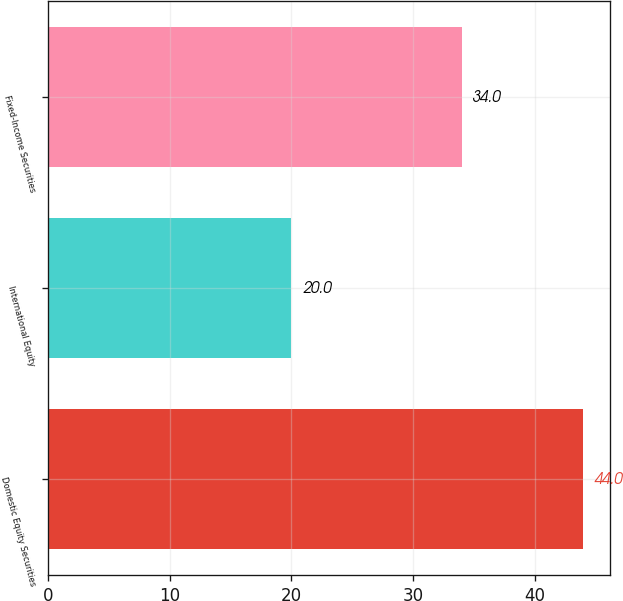Convert chart to OTSL. <chart><loc_0><loc_0><loc_500><loc_500><bar_chart><fcel>Domestic Equity Securities<fcel>International Equity<fcel>Fixed-Income Securities<nl><fcel>44<fcel>20<fcel>34<nl></chart> 